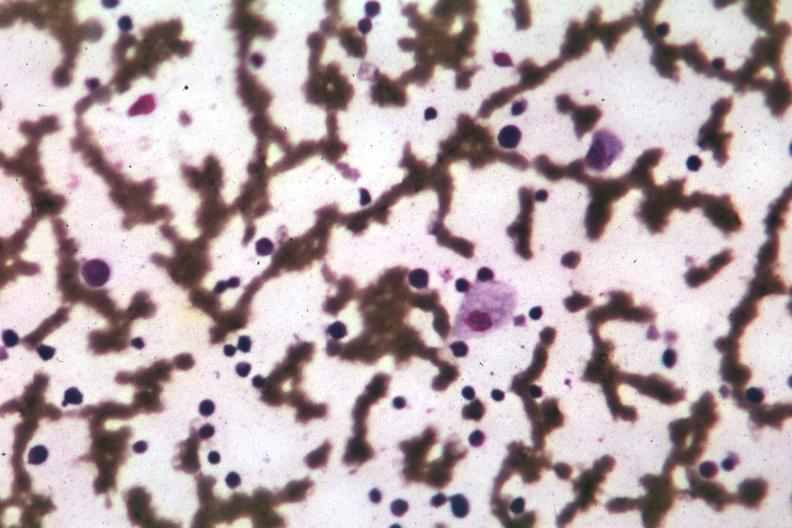what is present?
Answer the question using a single word or phrase. Gaucher cell 